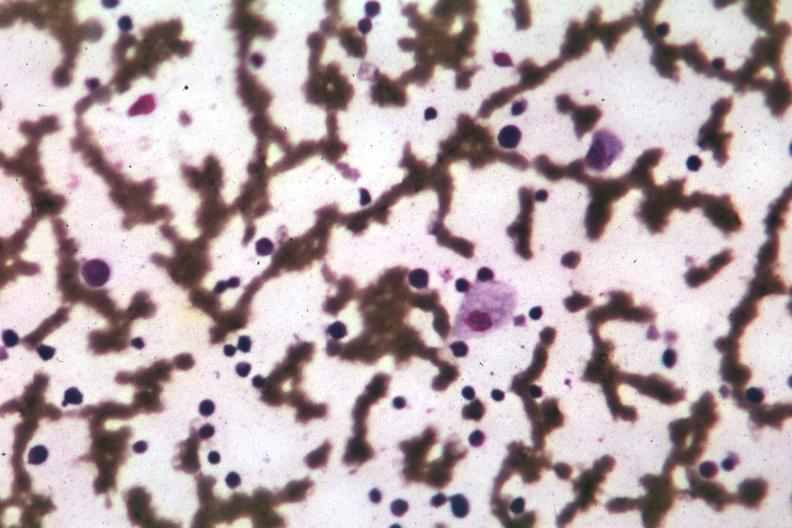what is present?
Answer the question using a single word or phrase. Gaucher cell 